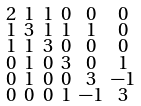Convert formula to latex. <formula><loc_0><loc_0><loc_500><loc_500>\begin{smallmatrix} 2 & 1 & 1 & 0 & 0 & 0 \\ 1 & 3 & 1 & 1 & 1 & 0 \\ 1 & 1 & 3 & 0 & 0 & 0 \\ 0 & 1 & 0 & 3 & 0 & 1 \\ 0 & 1 & 0 & 0 & 3 & - 1 \\ 0 & 0 & 0 & 1 & - 1 & 3 \end{smallmatrix}</formula> 